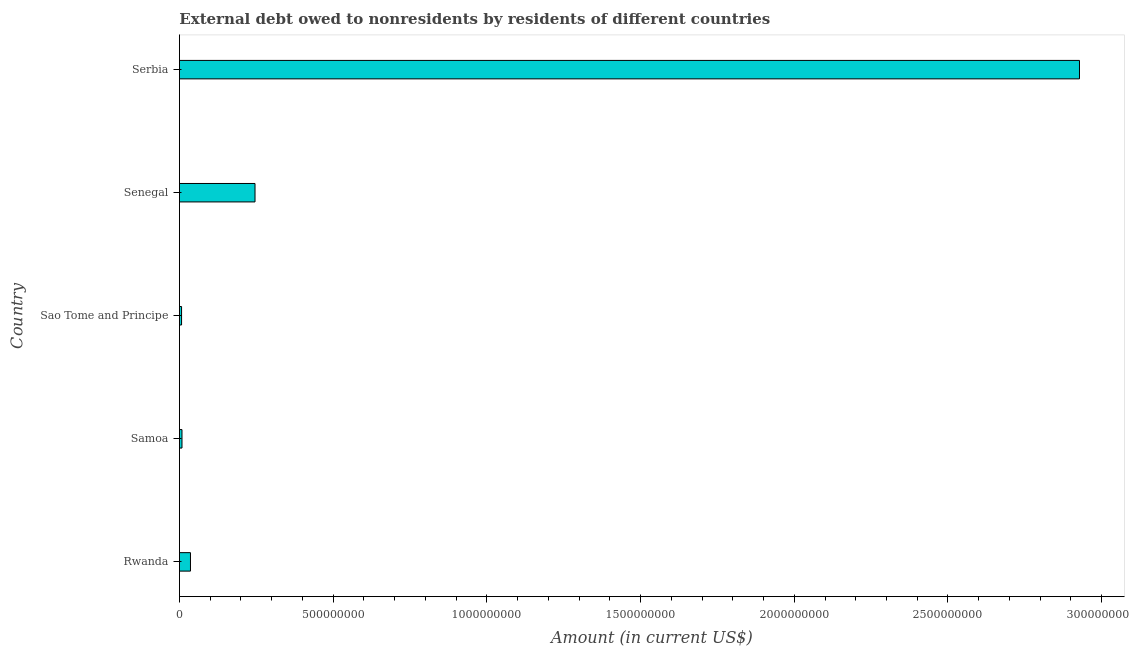Does the graph contain any zero values?
Provide a short and direct response. No. Does the graph contain grids?
Keep it short and to the point. No. What is the title of the graph?
Give a very brief answer. External debt owed to nonresidents by residents of different countries. What is the label or title of the X-axis?
Your answer should be compact. Amount (in current US$). What is the debt in Senegal?
Make the answer very short. 2.46e+08. Across all countries, what is the maximum debt?
Offer a very short reply. 2.93e+09. Across all countries, what is the minimum debt?
Give a very brief answer. 7.01e+06. In which country was the debt maximum?
Your answer should be compact. Serbia. In which country was the debt minimum?
Offer a very short reply. Sao Tome and Principe. What is the sum of the debt?
Ensure brevity in your answer.  3.23e+09. What is the difference between the debt in Sao Tome and Principe and Senegal?
Your response must be concise. -2.39e+08. What is the average debt per country?
Give a very brief answer. 6.45e+08. What is the median debt?
Your response must be concise. 3.60e+07. What is the ratio of the debt in Samoa to that in Senegal?
Your answer should be compact. 0.03. What is the difference between the highest and the second highest debt?
Provide a short and direct response. 2.68e+09. What is the difference between the highest and the lowest debt?
Your answer should be compact. 2.92e+09. In how many countries, is the debt greater than the average debt taken over all countries?
Provide a succinct answer. 1. How many countries are there in the graph?
Ensure brevity in your answer.  5. What is the Amount (in current US$) in Rwanda?
Offer a very short reply. 3.60e+07. What is the Amount (in current US$) in Samoa?
Offer a terse response. 8.38e+06. What is the Amount (in current US$) in Sao Tome and Principe?
Your response must be concise. 7.01e+06. What is the Amount (in current US$) of Senegal?
Give a very brief answer. 2.46e+08. What is the Amount (in current US$) in Serbia?
Provide a succinct answer. 2.93e+09. What is the difference between the Amount (in current US$) in Rwanda and Samoa?
Make the answer very short. 2.76e+07. What is the difference between the Amount (in current US$) in Rwanda and Sao Tome and Principe?
Offer a terse response. 2.90e+07. What is the difference between the Amount (in current US$) in Rwanda and Senegal?
Your answer should be very brief. -2.10e+08. What is the difference between the Amount (in current US$) in Rwanda and Serbia?
Your answer should be very brief. -2.89e+09. What is the difference between the Amount (in current US$) in Samoa and Sao Tome and Principe?
Offer a very short reply. 1.37e+06. What is the difference between the Amount (in current US$) in Samoa and Senegal?
Keep it short and to the point. -2.38e+08. What is the difference between the Amount (in current US$) in Samoa and Serbia?
Your answer should be compact. -2.92e+09. What is the difference between the Amount (in current US$) in Sao Tome and Principe and Senegal?
Give a very brief answer. -2.39e+08. What is the difference between the Amount (in current US$) in Sao Tome and Principe and Serbia?
Give a very brief answer. -2.92e+09. What is the difference between the Amount (in current US$) in Senegal and Serbia?
Provide a short and direct response. -2.68e+09. What is the ratio of the Amount (in current US$) in Rwanda to that in Samoa?
Keep it short and to the point. 4.29. What is the ratio of the Amount (in current US$) in Rwanda to that in Sao Tome and Principe?
Your response must be concise. 5.13. What is the ratio of the Amount (in current US$) in Rwanda to that in Senegal?
Ensure brevity in your answer.  0.15. What is the ratio of the Amount (in current US$) in Rwanda to that in Serbia?
Offer a terse response. 0.01. What is the ratio of the Amount (in current US$) in Samoa to that in Sao Tome and Principe?
Provide a succinct answer. 1.2. What is the ratio of the Amount (in current US$) in Samoa to that in Senegal?
Your response must be concise. 0.03. What is the ratio of the Amount (in current US$) in Samoa to that in Serbia?
Your response must be concise. 0. What is the ratio of the Amount (in current US$) in Sao Tome and Principe to that in Senegal?
Make the answer very short. 0.03. What is the ratio of the Amount (in current US$) in Sao Tome and Principe to that in Serbia?
Keep it short and to the point. 0. What is the ratio of the Amount (in current US$) in Senegal to that in Serbia?
Keep it short and to the point. 0.08. 